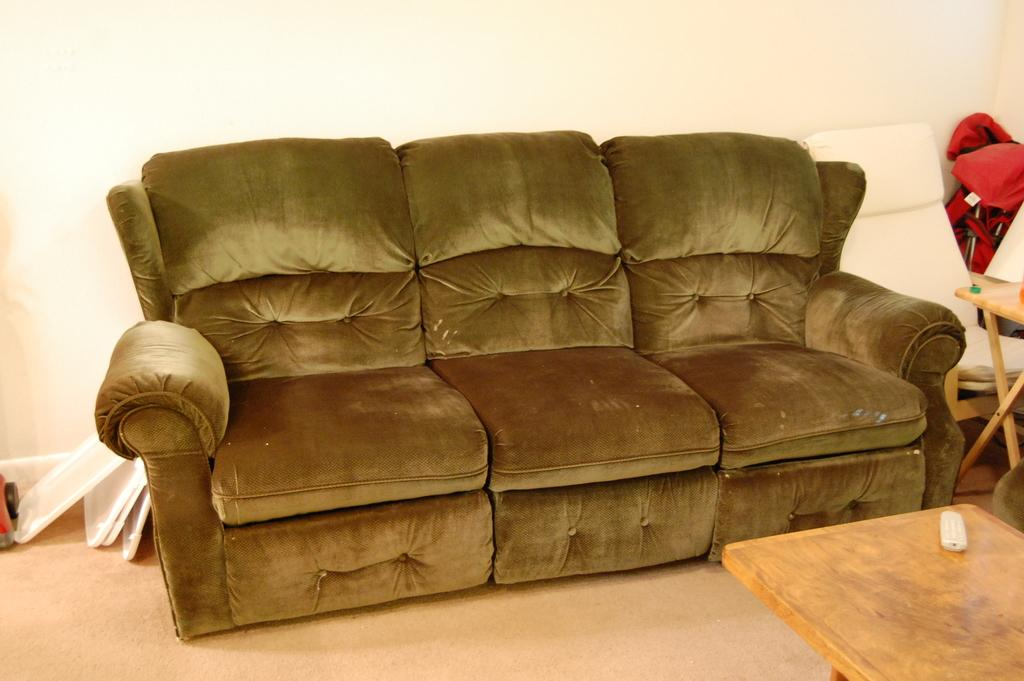What type of furniture is present in the image? There is a sofa table in the image. What else can be seen in the image besides the furniture? There is a wall in the image. How many roses are on the wall in the image? There are no roses present on the wall in the image. 